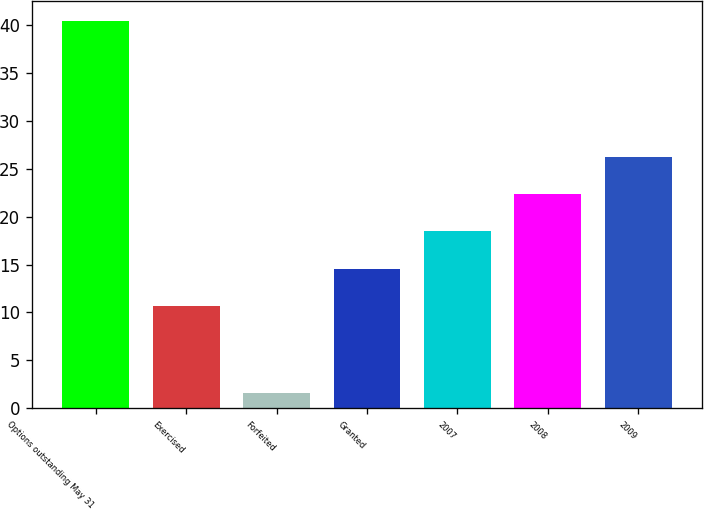<chart> <loc_0><loc_0><loc_500><loc_500><bar_chart><fcel>Options outstanding May 31<fcel>Exercised<fcel>Forfeited<fcel>Granted<fcel>2007<fcel>2008<fcel>2009<nl><fcel>40.48<fcel>10.7<fcel>1.6<fcel>14.58<fcel>18.46<fcel>22.34<fcel>26.22<nl></chart> 